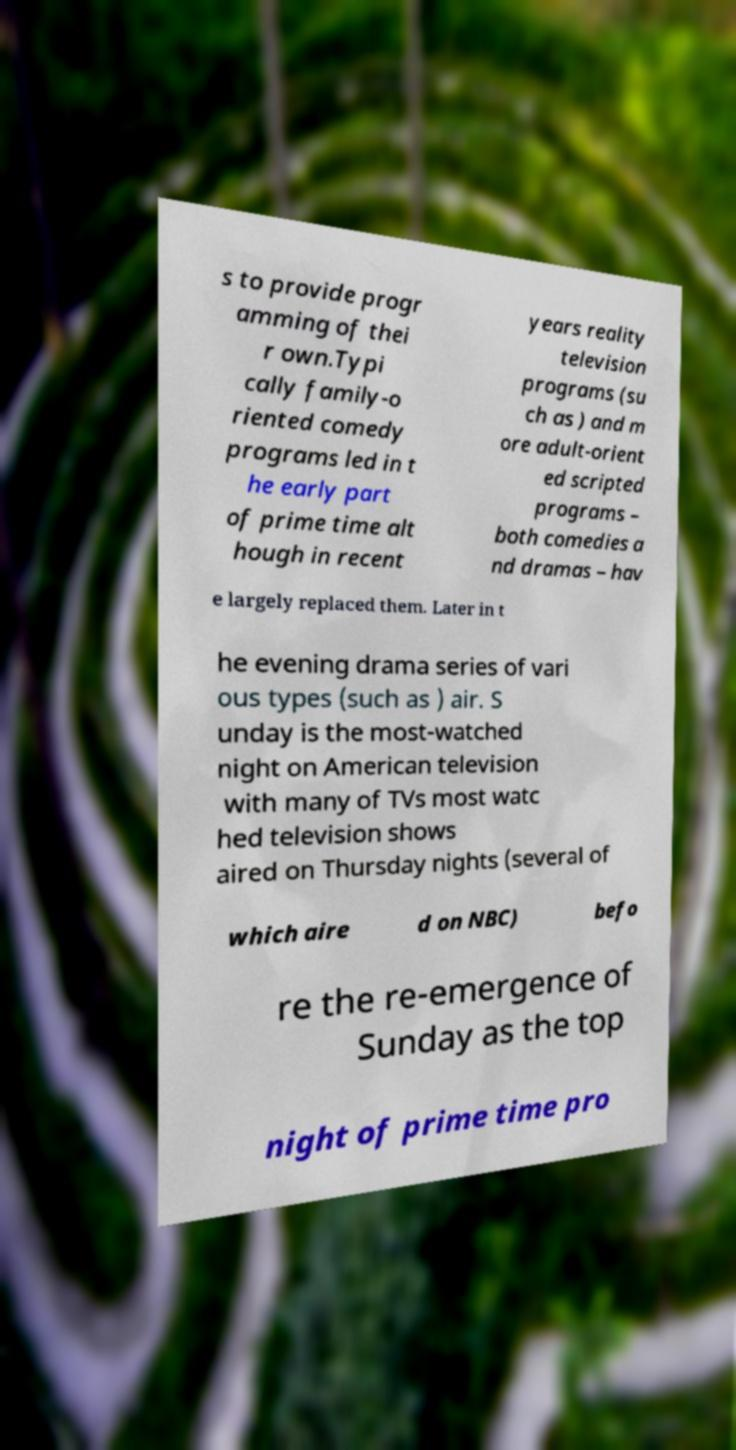Can you read and provide the text displayed in the image?This photo seems to have some interesting text. Can you extract and type it out for me? s to provide progr amming of thei r own.Typi cally family-o riented comedy programs led in t he early part of prime time alt hough in recent years reality television programs (su ch as ) and m ore adult-orient ed scripted programs – both comedies a nd dramas – hav e largely replaced them. Later in t he evening drama series of vari ous types (such as ) air. S unday is the most-watched night on American television with many of TVs most watc hed television shows aired on Thursday nights (several of which aire d on NBC) befo re the re-emergence of Sunday as the top night of prime time pro 